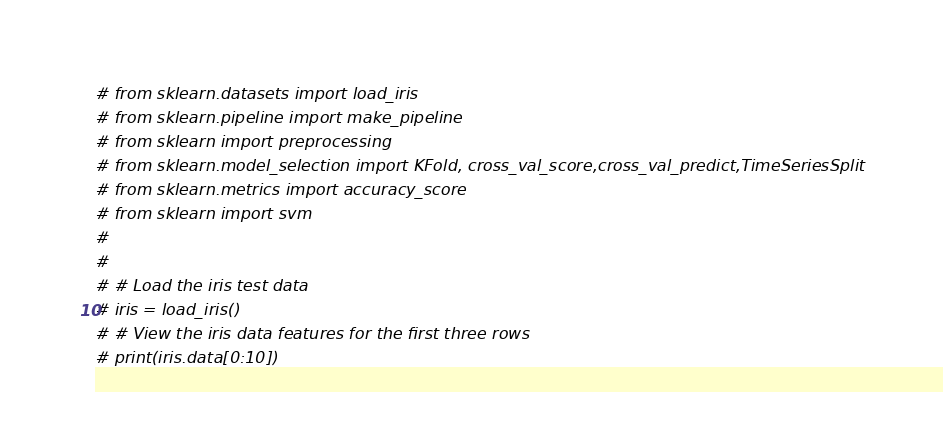<code> <loc_0><loc_0><loc_500><loc_500><_Python_># from sklearn.datasets import load_iris
# from sklearn.pipeline import make_pipeline
# from sklearn import preprocessing
# from sklearn.model_selection import KFold, cross_val_score,cross_val_predict,TimeSeriesSplit
# from sklearn.metrics import accuracy_score
# from sklearn import svm
#
#
# # Load the iris test data
# iris = load_iris()
# # View the iris data features for the first three rows
# print(iris.data[0:10])</code> 